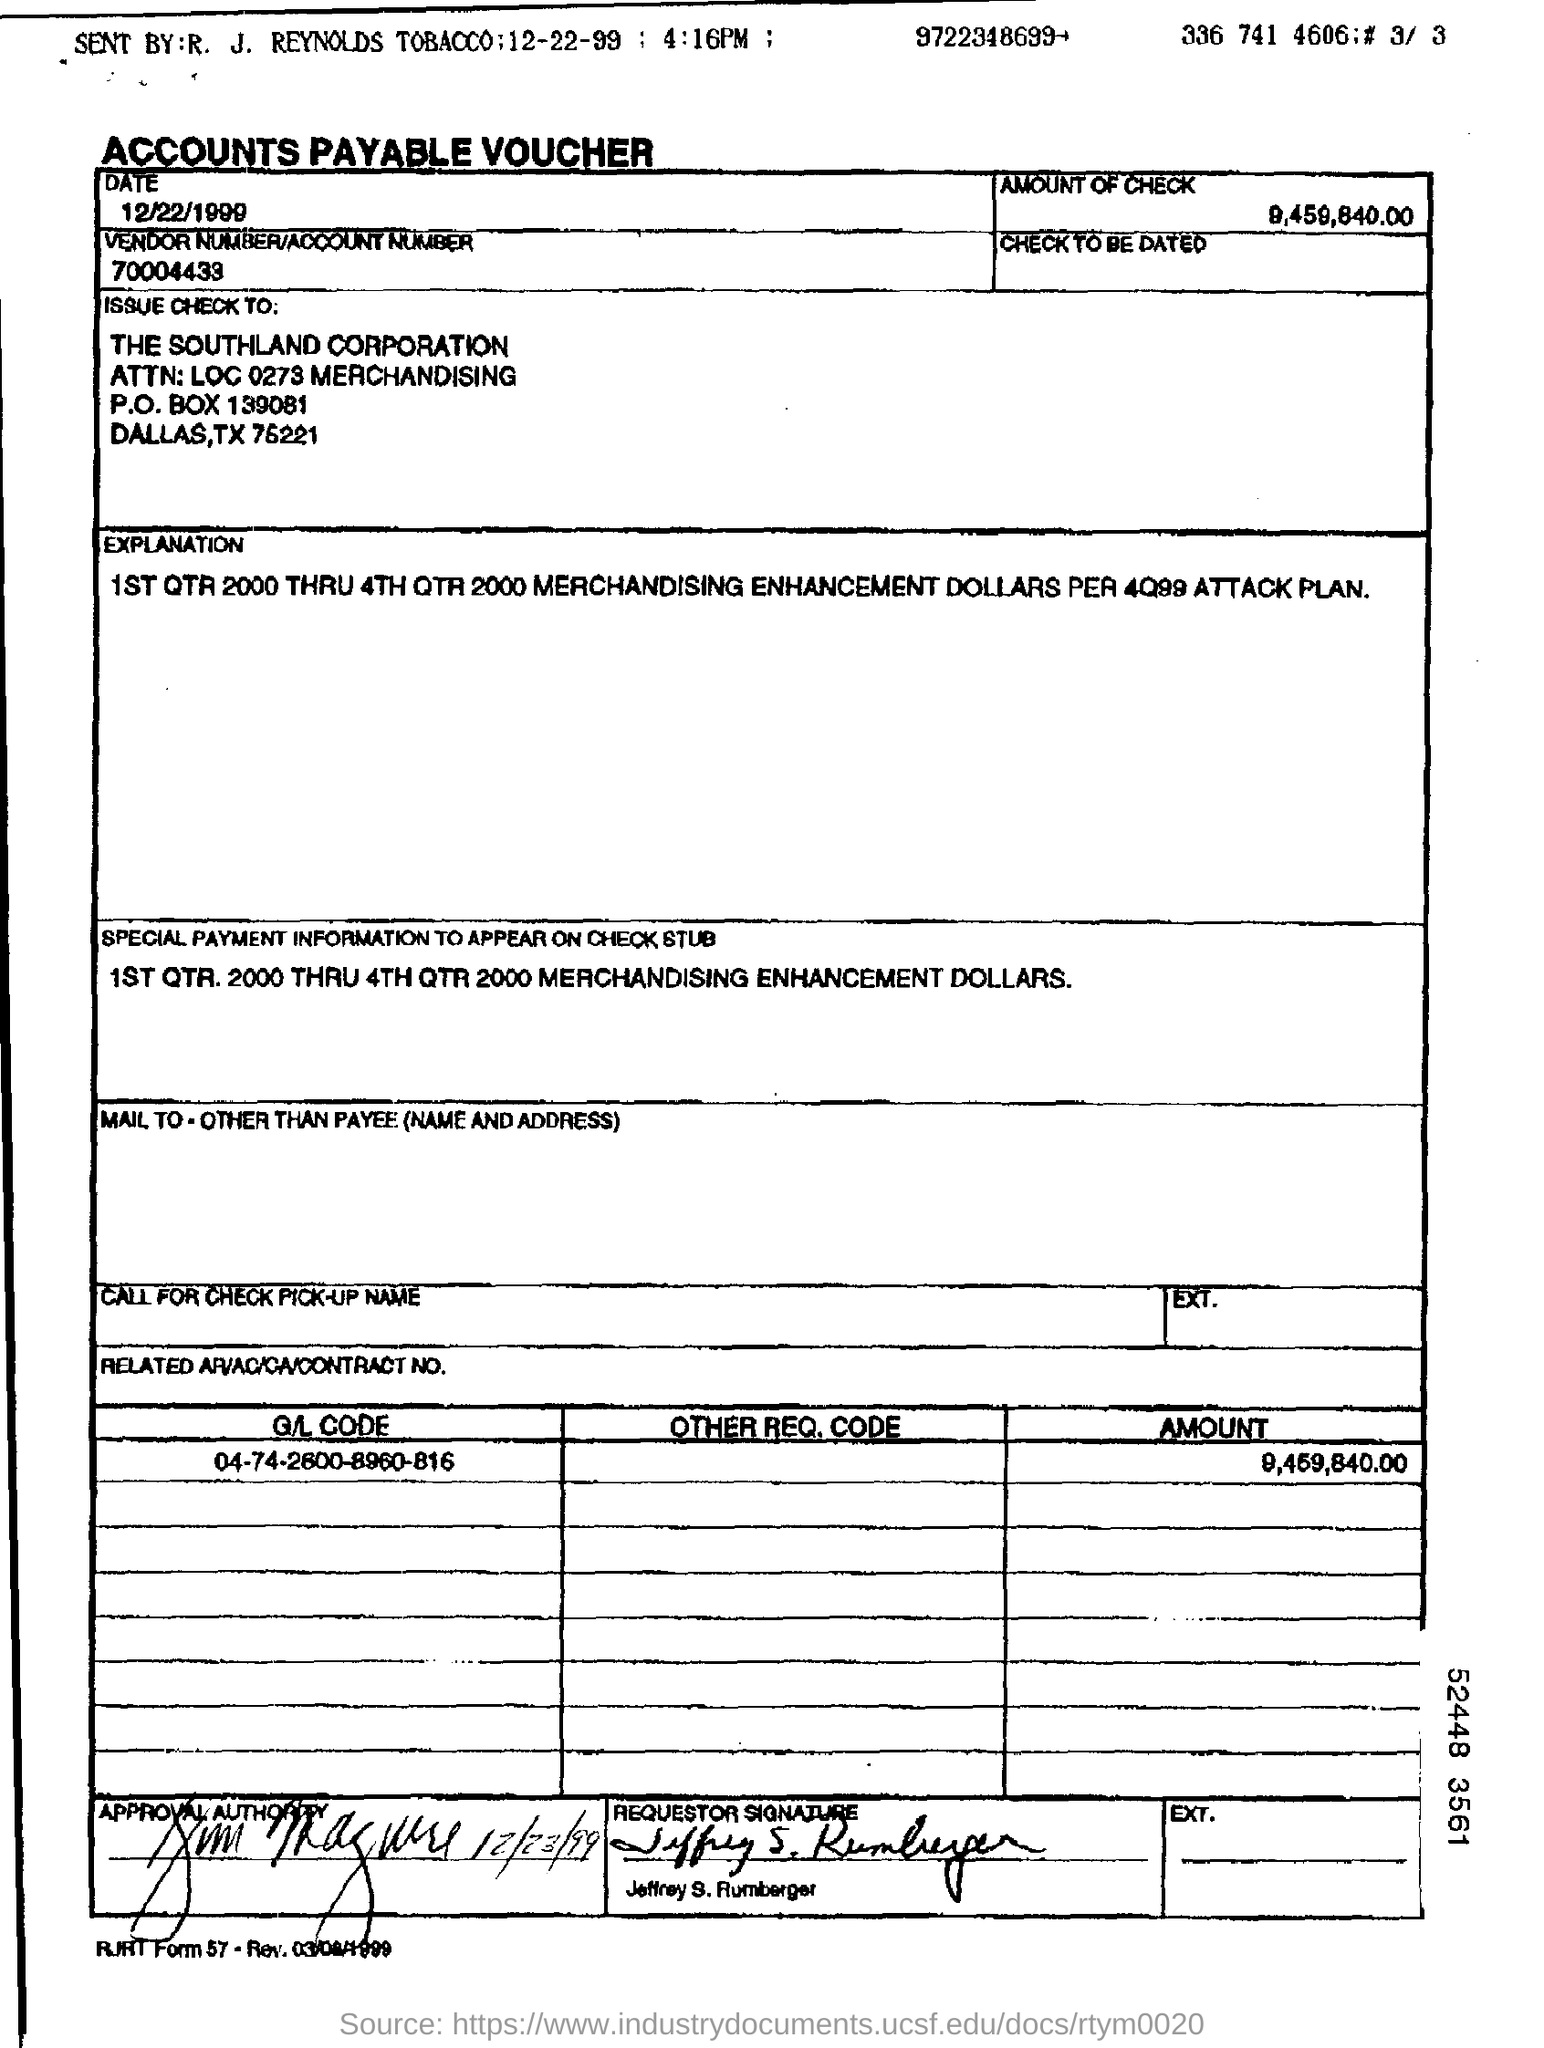Specify some key components in this picture. The requestor mentioned in the voucher is Jeffrey S. Rumberger. This type of voucher is an accounts payable voucher. The vendor number/account number specified in the voucher is 70004433... The vendor number mentioned in the voucher is 70004433... The check amount mentioned in the voucher is 9,459,840.00. 